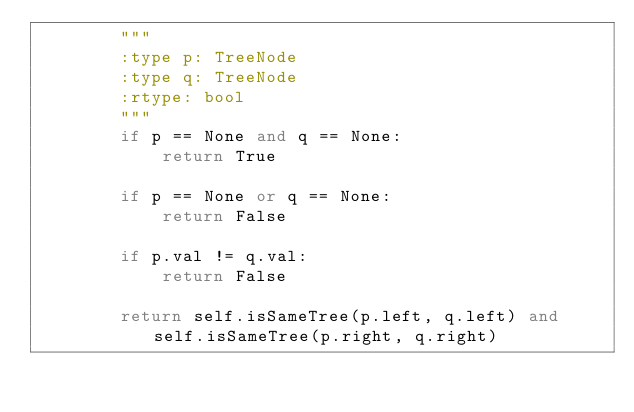<code> <loc_0><loc_0><loc_500><loc_500><_Python_>        """
        :type p: TreeNode
        :type q: TreeNode
        :rtype: bool
        """
        if p == None and q == None:
            return True
            
        if p == None or q == None:
            return False
        
        if p.val != q.val:
            return False
            
        return self.isSameTree(p.left, q.left) and self.isSameTree(p.right, q.right)
</code> 